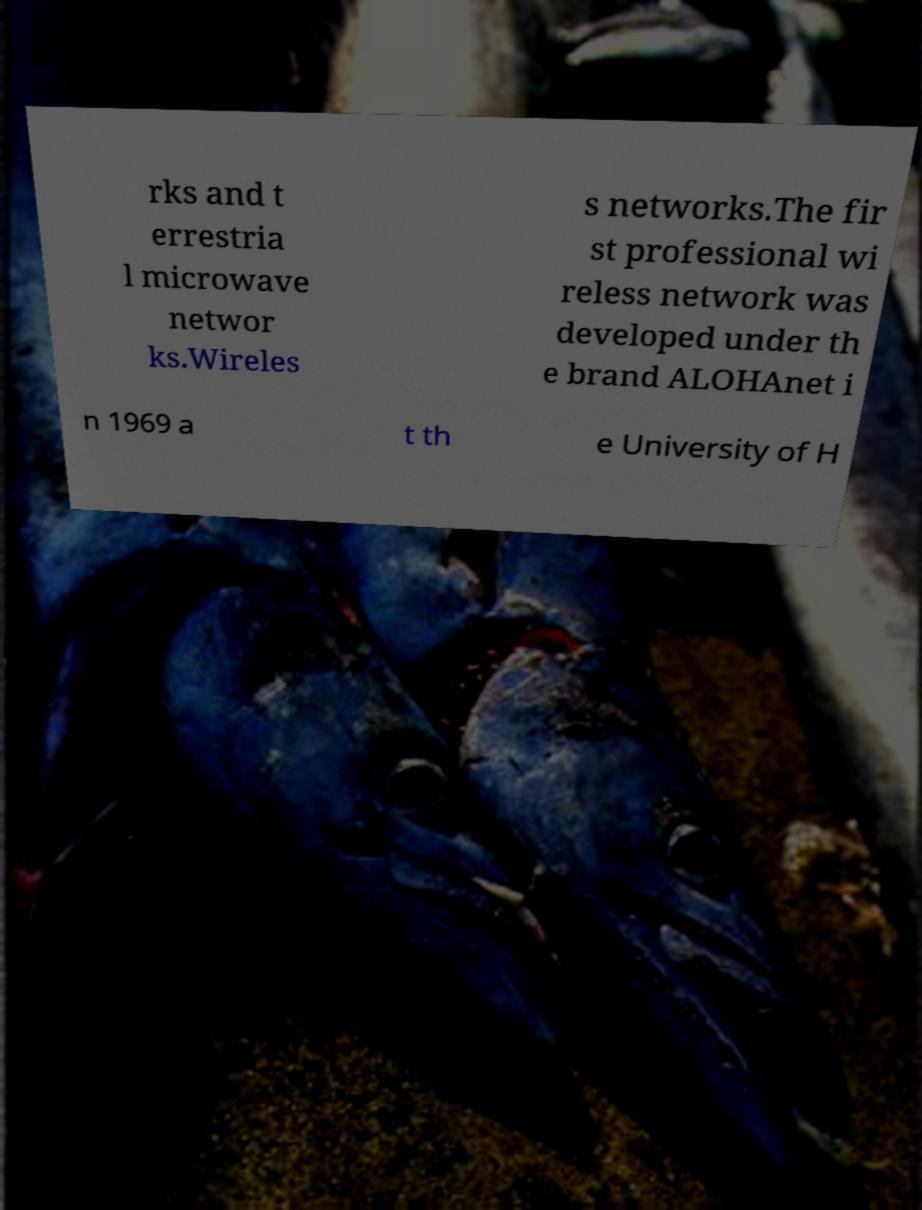What messages or text are displayed in this image? I need them in a readable, typed format. rks and t errestria l microwave networ ks.Wireles s networks.The fir st professional wi reless network was developed under th e brand ALOHAnet i n 1969 a t th e University of H 